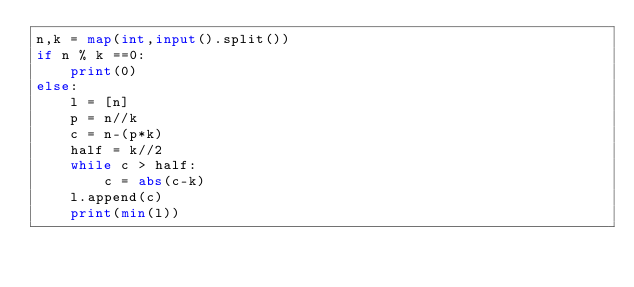<code> <loc_0><loc_0><loc_500><loc_500><_Python_>n,k = map(int,input().split())
if n % k ==0:
    print(0)
else:
    l = [n]
    p = n//k
    c = n-(p*k)
    half = k//2
    while c > half:
        c = abs(c-k)
    l.append(c)
    print(min(l))</code> 